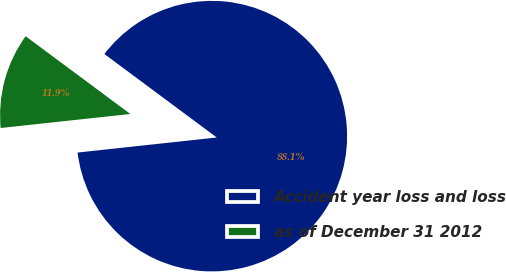Convert chart. <chart><loc_0><loc_0><loc_500><loc_500><pie_chart><fcel>Accident year loss and loss<fcel>as of December 31 2012<nl><fcel>88.12%<fcel>11.88%<nl></chart> 